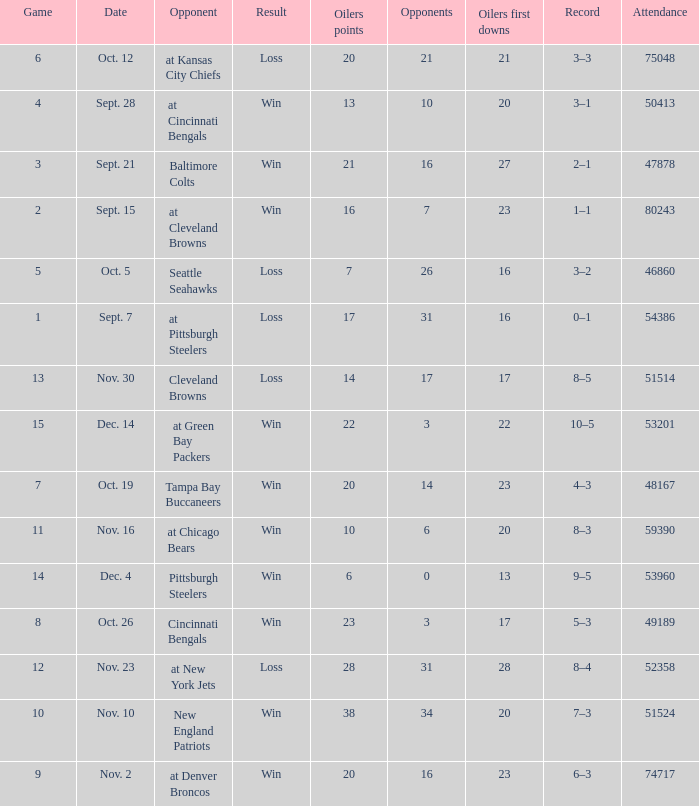What was the total opponents points for the game were the Oilers scored 21? 16.0. 